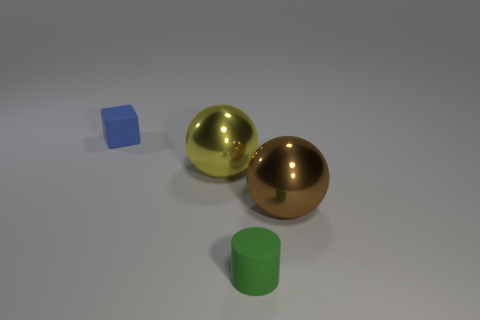What size is the yellow sphere on the left side of the tiny rubber object in front of the rubber block?
Offer a terse response. Large. Are there an equal number of large brown things that are in front of the brown metallic ball and small rubber cylinders that are left of the green rubber object?
Make the answer very short. Yes. Is there anything else that is the same size as the green cylinder?
Ensure brevity in your answer.  Yes. There is a tiny cylinder that is the same material as the small cube; what is its color?
Your response must be concise. Green. Does the tiny blue cube have the same material as the brown object behind the small cylinder?
Offer a terse response. No. The object that is both to the right of the blue cube and left of the cylinder is what color?
Ensure brevity in your answer.  Yellow. What number of cylinders are either tiny green rubber things or big things?
Make the answer very short. 1. There is a large yellow metal thing; is it the same shape as the small thing behind the tiny matte cylinder?
Provide a succinct answer. No. What size is the object that is both on the right side of the large yellow metal object and on the left side of the brown metal sphere?
Make the answer very short. Small. There is a big brown thing; what shape is it?
Provide a short and direct response. Sphere. 